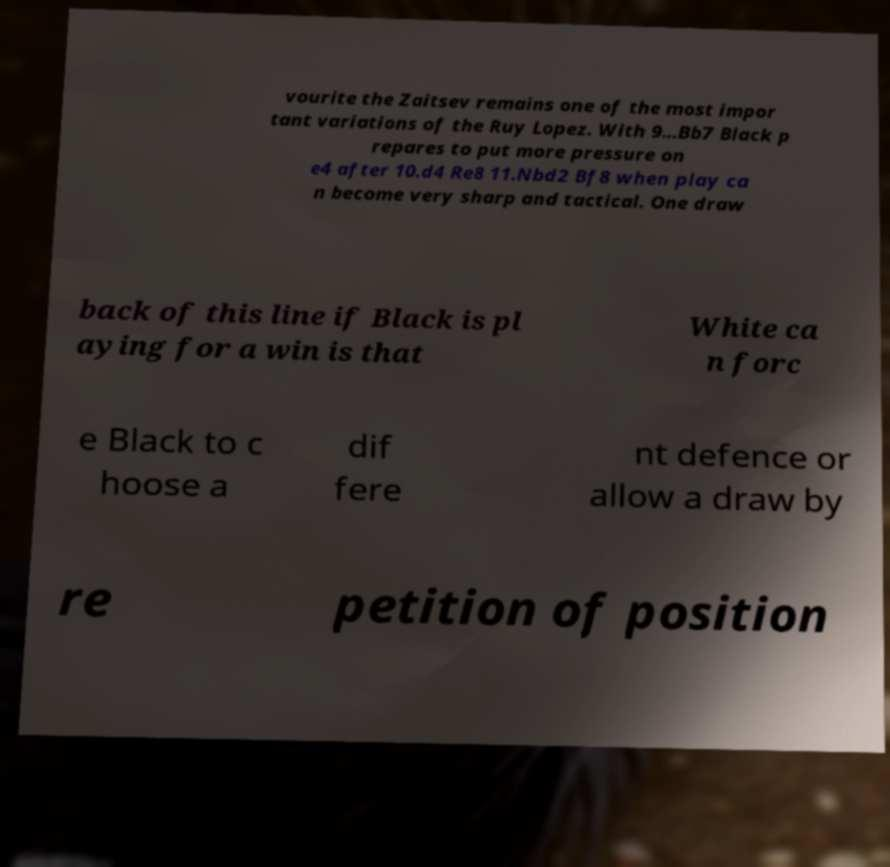For documentation purposes, I need the text within this image transcribed. Could you provide that? vourite the Zaitsev remains one of the most impor tant variations of the Ruy Lopez. With 9...Bb7 Black p repares to put more pressure on e4 after 10.d4 Re8 11.Nbd2 Bf8 when play ca n become very sharp and tactical. One draw back of this line if Black is pl aying for a win is that White ca n forc e Black to c hoose a dif fere nt defence or allow a draw by re petition of position 